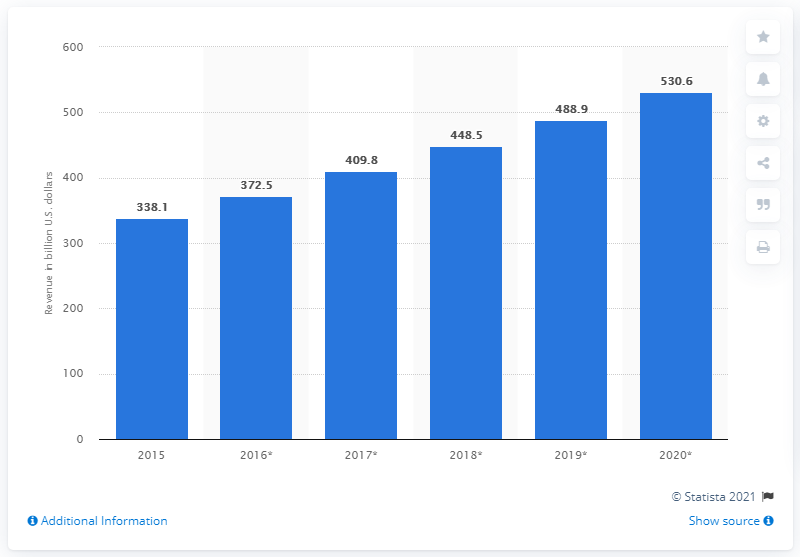Outline some significant characteristics in this image. In 2015, U.S. retail e-commerce spending totaled approximately $338.1 billion. In 2020, it is projected that e-commerce spending in the United States will reach a total of 530.6 billion dollars. 